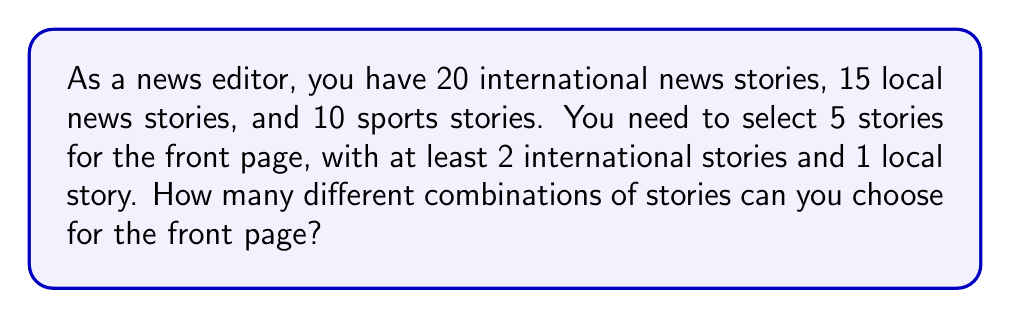Solve this math problem. Let's approach this step-by-step using the combination formula and the multiplication principle:

1) First, we need to select at least 2 international stories and 1 local story. Let's consider the cases:

   Case 1: 2 international, 1 local, 2 others
   Case 2: 2 international, 2 local, 1 other
   Case 3: 3 international, 1 local, 1 other
   Case 4: 3 international, 2 local, 0 other

2) Let's calculate each case:

   Case 1: 
   - Choose 2 international: $\binom{20}{2}$
   - Choose 1 local: $\binom{15}{1}$
   - Choose 2 from remaining (13 local + 10 sports): $\binom{23}{2}$
   Total: $\binom{20}{2} \cdot \binom{15}{1} \cdot \binom{23}{2}$

   Case 2:
   - Choose 2 international: $\binom{20}{2}$
   - Choose 2 local: $\binom{15}{2}$
   - Choose 1 from remaining (10 sports): $\binom{10}{1}$
   Total: $\binom{20}{2} \cdot \binom{15}{2} \cdot \binom{10}{1}$

   Case 3:
   - Choose 3 international: $\binom{20}{3}$
   - Choose 1 local: $\binom{15}{1}$
   - Choose 1 from remaining (14 local + 10 sports): $\binom{24}{1}$
   Total: $\binom{20}{3} \cdot \binom{15}{1} \cdot \binom{24}{1}$

   Case 4:
   - Choose 3 international: $\binom{20}{3}$
   - Choose 2 local: $\binom{15}{2}$
   Total: $\binom{20}{3} \cdot \binom{15}{2}$

3) Sum up all cases:

   $$\binom{20}{2} \cdot \binom{15}{1} \cdot \binom{23}{2} + \binom{20}{2} \cdot \binom{15}{2} \cdot \binom{10}{1} + \binom{20}{3} \cdot \binom{15}{1} \cdot \binom{24}{1} + \binom{20}{3} \cdot \binom{15}{2}$$

4) Calculate:
   $$(190 \cdot 15 \cdot 253) + (190 \cdot 105 \cdot 10) + (1140 \cdot 15 \cdot 24) + (1140 \cdot 105)$$
   $$= 721,050 + 199,500 + 410,400 + 119,700$$
   $$= 1,450,650$$
Answer: 1,450,650 